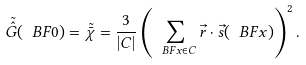Convert formula to latex. <formula><loc_0><loc_0><loc_500><loc_500>\tilde { \hat { G } } ( \ B F { 0 } ) = \tilde { \bar { \chi } } = \frac { 3 } { | C | } \left ( \sum _ { \ B F { x } \in C } \vec { r } \cdot \vec { s } ( \ B F { x } ) \right ) ^ { 2 } .</formula> 